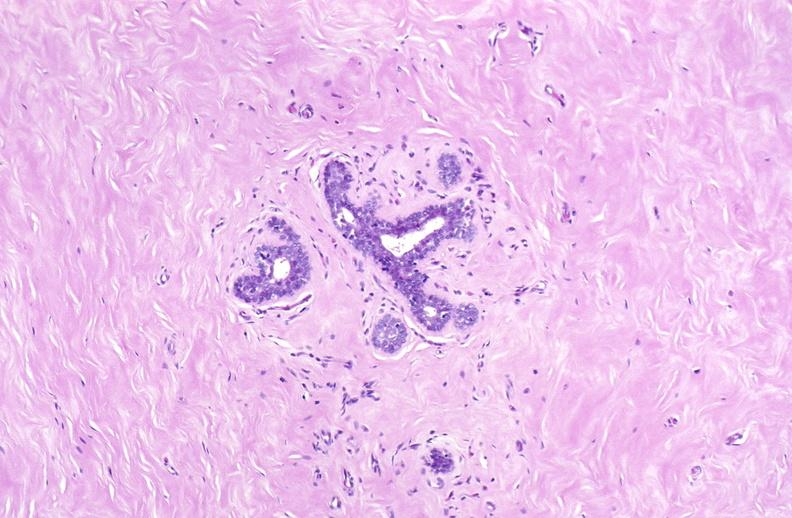does this image show breast, fibroadenoma?
Answer the question using a single word or phrase. Yes 